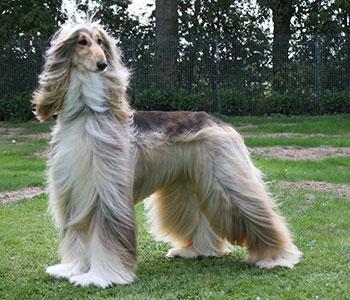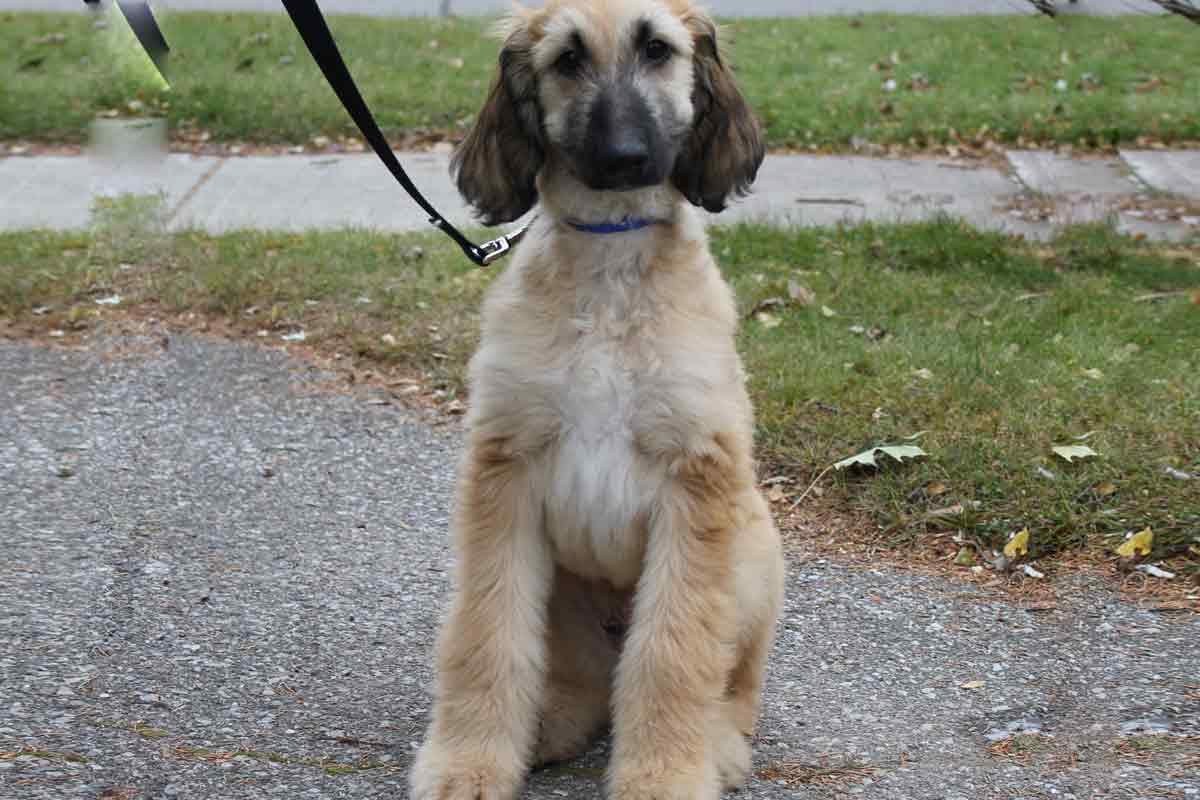The first image is the image on the left, the second image is the image on the right. For the images displayed, is the sentence "Only the dog in the left image is standing on all fours." factually correct? Answer yes or no. Yes. 